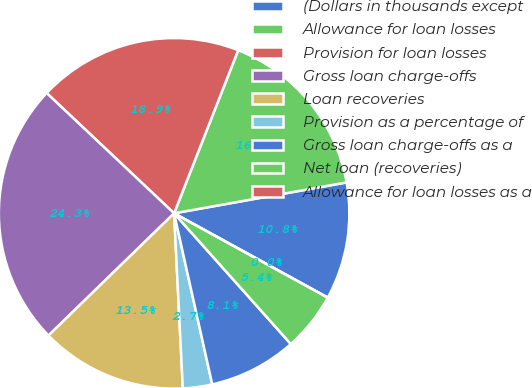<chart> <loc_0><loc_0><loc_500><loc_500><pie_chart><fcel>(Dollars in thousands except<fcel>Allowance for loan losses<fcel>Provision for loan losses<fcel>Gross loan charge-offs<fcel>Loan recoveries<fcel>Provision as a percentage of<fcel>Gross loan charge-offs as a<fcel>Net loan (recoveries)<fcel>Allowance for loan losses as a<nl><fcel>10.81%<fcel>16.22%<fcel>18.92%<fcel>24.32%<fcel>13.51%<fcel>2.7%<fcel>8.11%<fcel>5.41%<fcel>0.0%<nl></chart> 